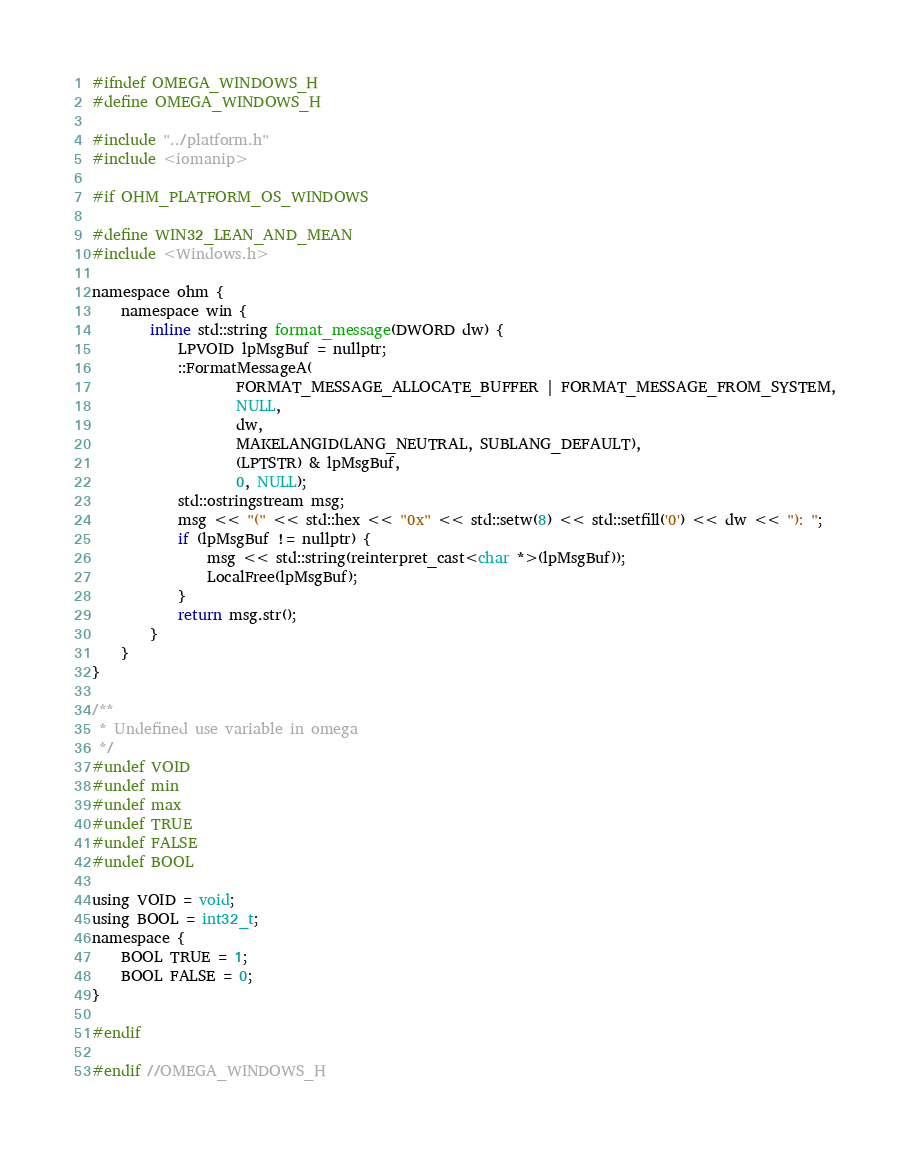Convert code to text. <code><loc_0><loc_0><loc_500><loc_500><_C_>
#ifndef OMEGA_WINDOWS_H
#define OMEGA_WINDOWS_H

#include "../platform.h"
#include <iomanip>

#if OHM_PLATFORM_OS_WINDOWS

#define WIN32_LEAN_AND_MEAN
#include <Windows.h>

namespace ohm {
    namespace win {
        inline std::string format_message(DWORD dw) {
            LPVOID lpMsgBuf = nullptr;
            ::FormatMessageA(
                    FORMAT_MESSAGE_ALLOCATE_BUFFER | FORMAT_MESSAGE_FROM_SYSTEM,
                    NULL,
                    dw,
                    MAKELANGID(LANG_NEUTRAL, SUBLANG_DEFAULT),
                    (LPTSTR) & lpMsgBuf,
                    0, NULL);
            std::ostringstream msg;
            msg << "(" << std::hex << "0x" << std::setw(8) << std::setfill('0') << dw << "): ";
            if (lpMsgBuf != nullptr) {
                msg << std::string(reinterpret_cast<char *>(lpMsgBuf));
                LocalFree(lpMsgBuf);
            }
            return msg.str();
        }
    }
}

/**
 * Undefined use variable in omega
 */
#undef VOID
#undef min
#undef max
#undef TRUE
#undef FALSE
#undef BOOL

using VOID = void;
using BOOL = int32_t;
namespace {
    BOOL TRUE = 1;
    BOOL FALSE = 0;
}

#endif

#endif //OMEGA_WINDOWS_H
</code> 